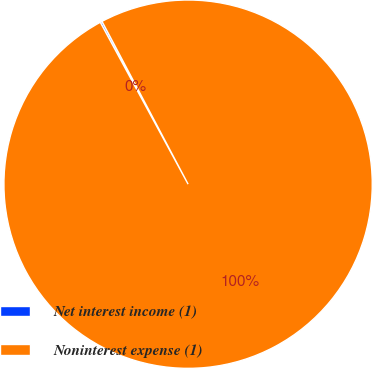<chart> <loc_0><loc_0><loc_500><loc_500><pie_chart><fcel>Net interest income (1)<fcel>Noninterest expense (1)<nl><fcel>0.17%<fcel>99.83%<nl></chart> 